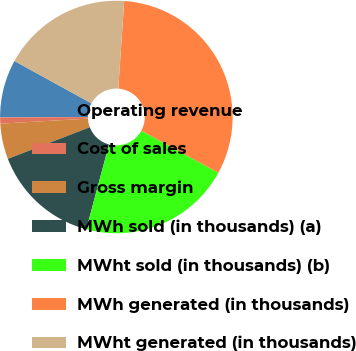<chart> <loc_0><loc_0><loc_500><loc_500><pie_chart><fcel>Operating revenue<fcel>Cost of sales<fcel>Gross margin<fcel>MWh sold (in thousands) (a)<fcel>MWht sold (in thousands) (b)<fcel>MWh generated (in thousands)<fcel>MWht generated (in thousands)<nl><fcel>8.06%<fcel>0.85%<fcel>4.95%<fcel>14.98%<fcel>21.19%<fcel>31.9%<fcel>18.08%<nl></chart> 